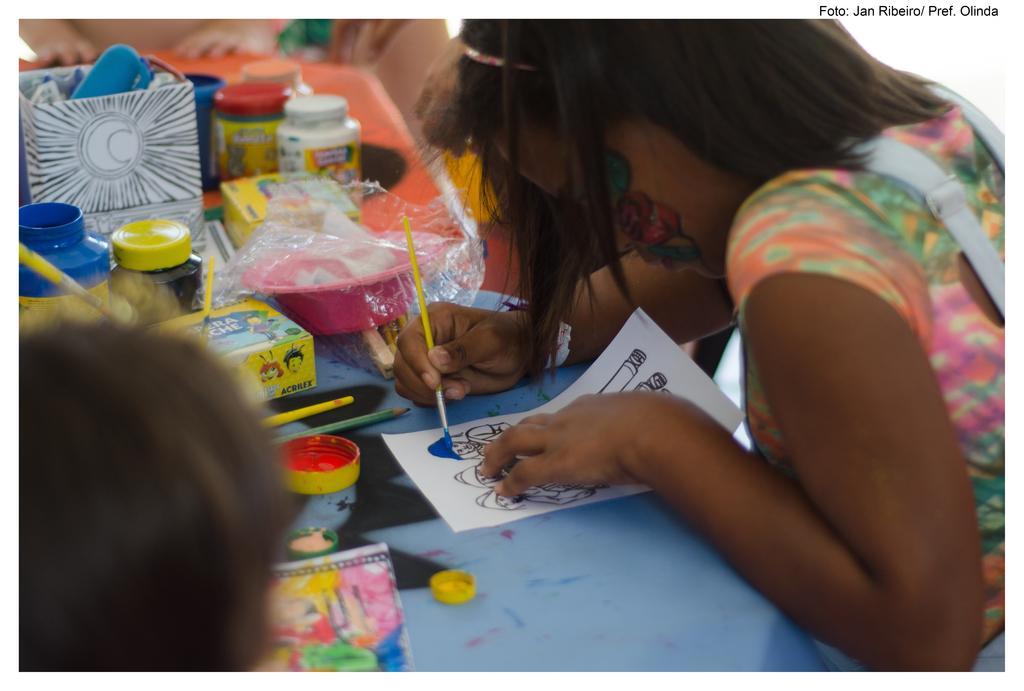Can you describe this image briefly? In this image we can see a girl painting. There is a table on which there are paints. To the left side of the image there is a boy. 